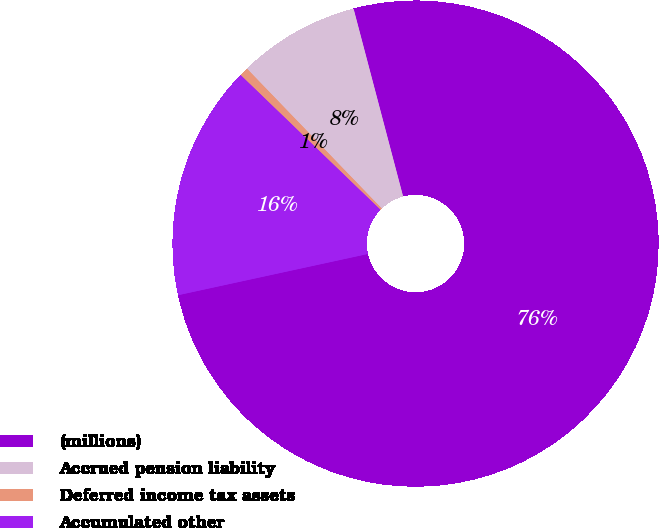Convert chart. <chart><loc_0><loc_0><loc_500><loc_500><pie_chart><fcel>(millions)<fcel>Accrued pension liability<fcel>Deferred income tax assets<fcel>Accumulated other<nl><fcel>75.7%<fcel>8.1%<fcel>0.59%<fcel>15.61%<nl></chart> 